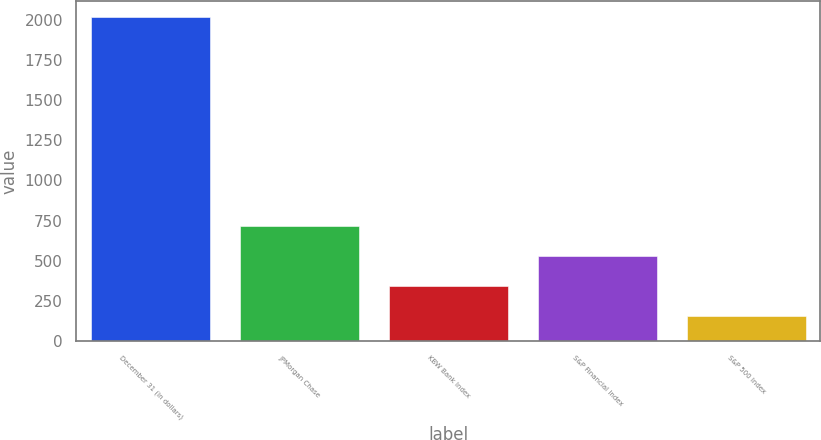Convert chart to OTSL. <chart><loc_0><loc_0><loc_500><loc_500><bar_chart><fcel>December 31 (in dollars)<fcel>JPMorgan Chase<fcel>KBW Bank Index<fcel>S&P Financial Index<fcel>S&P 500 Index<nl><fcel>2017<fcel>715.11<fcel>343.15<fcel>529.13<fcel>157.17<nl></chart> 